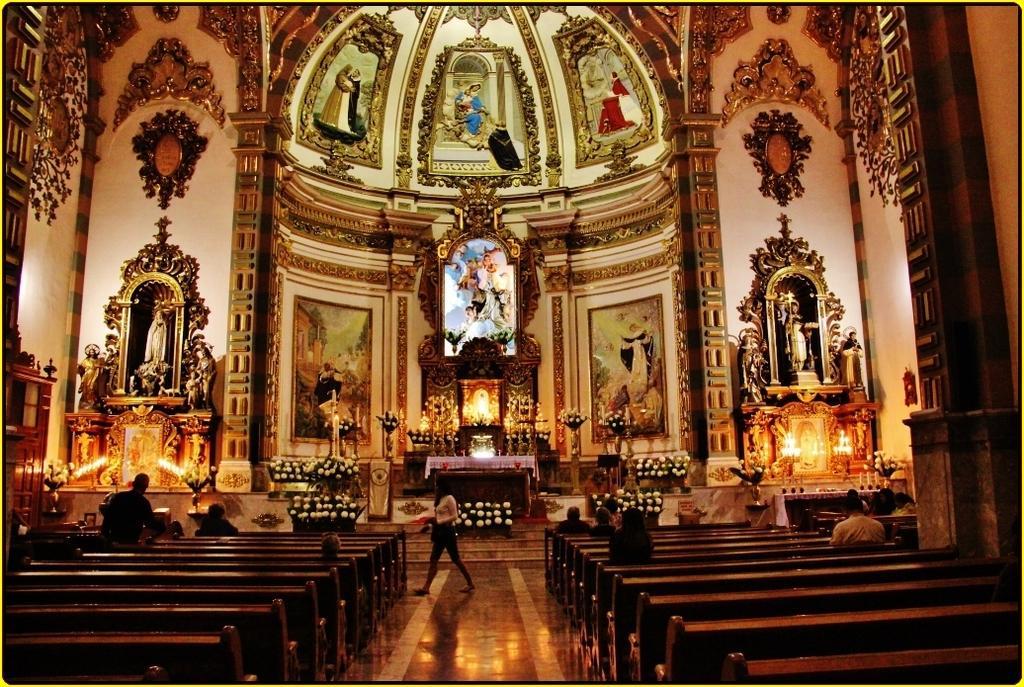Describe this image in one or two sentences. This is an inside view of a church. In this picture we can see a few sculptures. There are a few benches on the floor. We can see some flowers, candles and a table. 